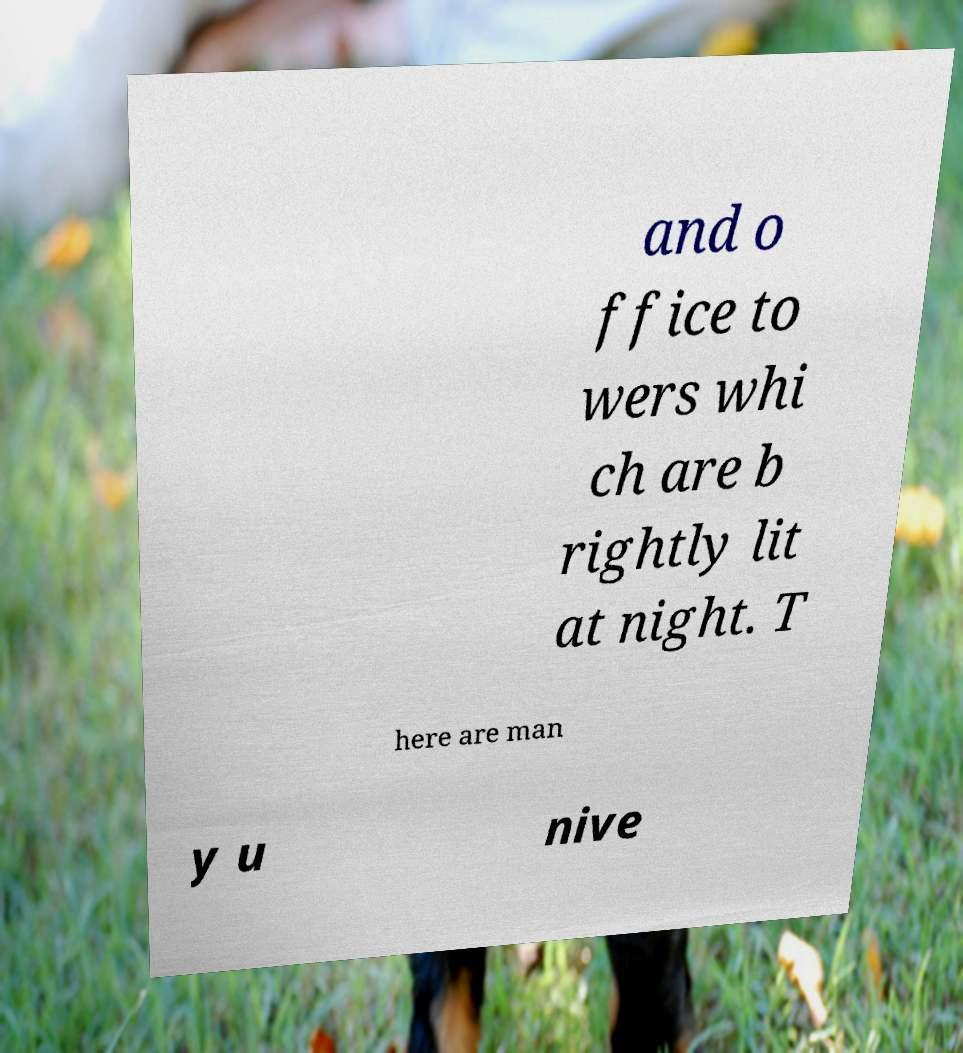Please read and relay the text visible in this image. What does it say? and o ffice to wers whi ch are b rightly lit at night. T here are man y u nive 